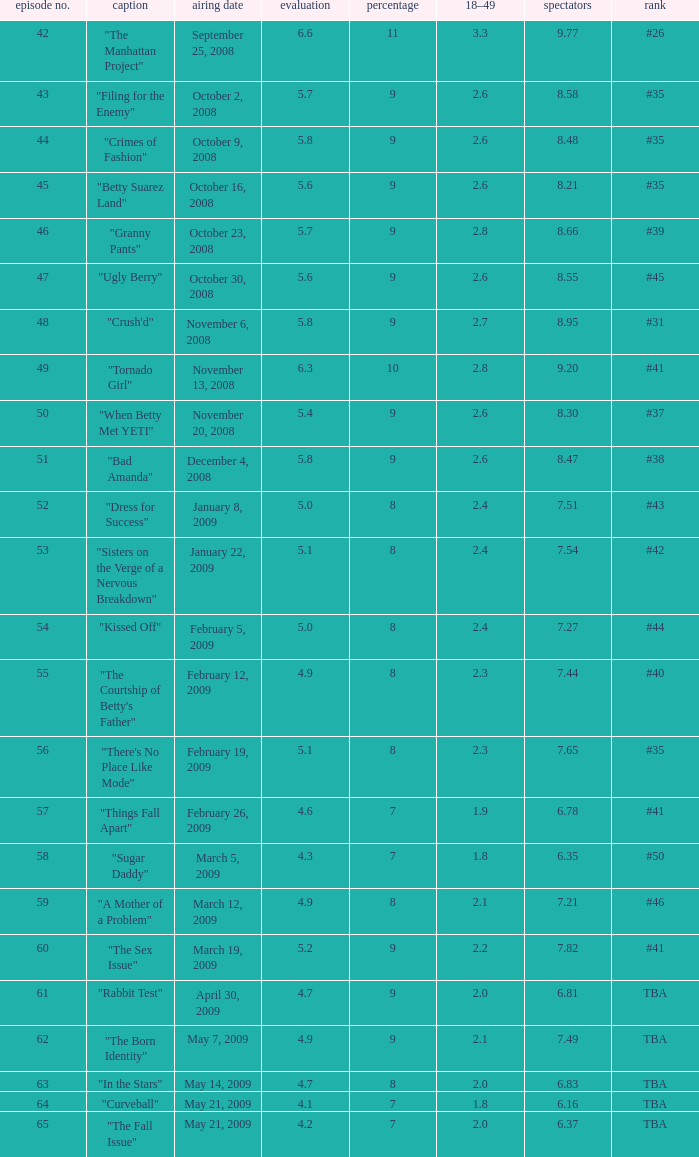What is the lowest Viewers that has an Episode #higher than 58 with a title of "curveball" less than 4.1 rating? None. 